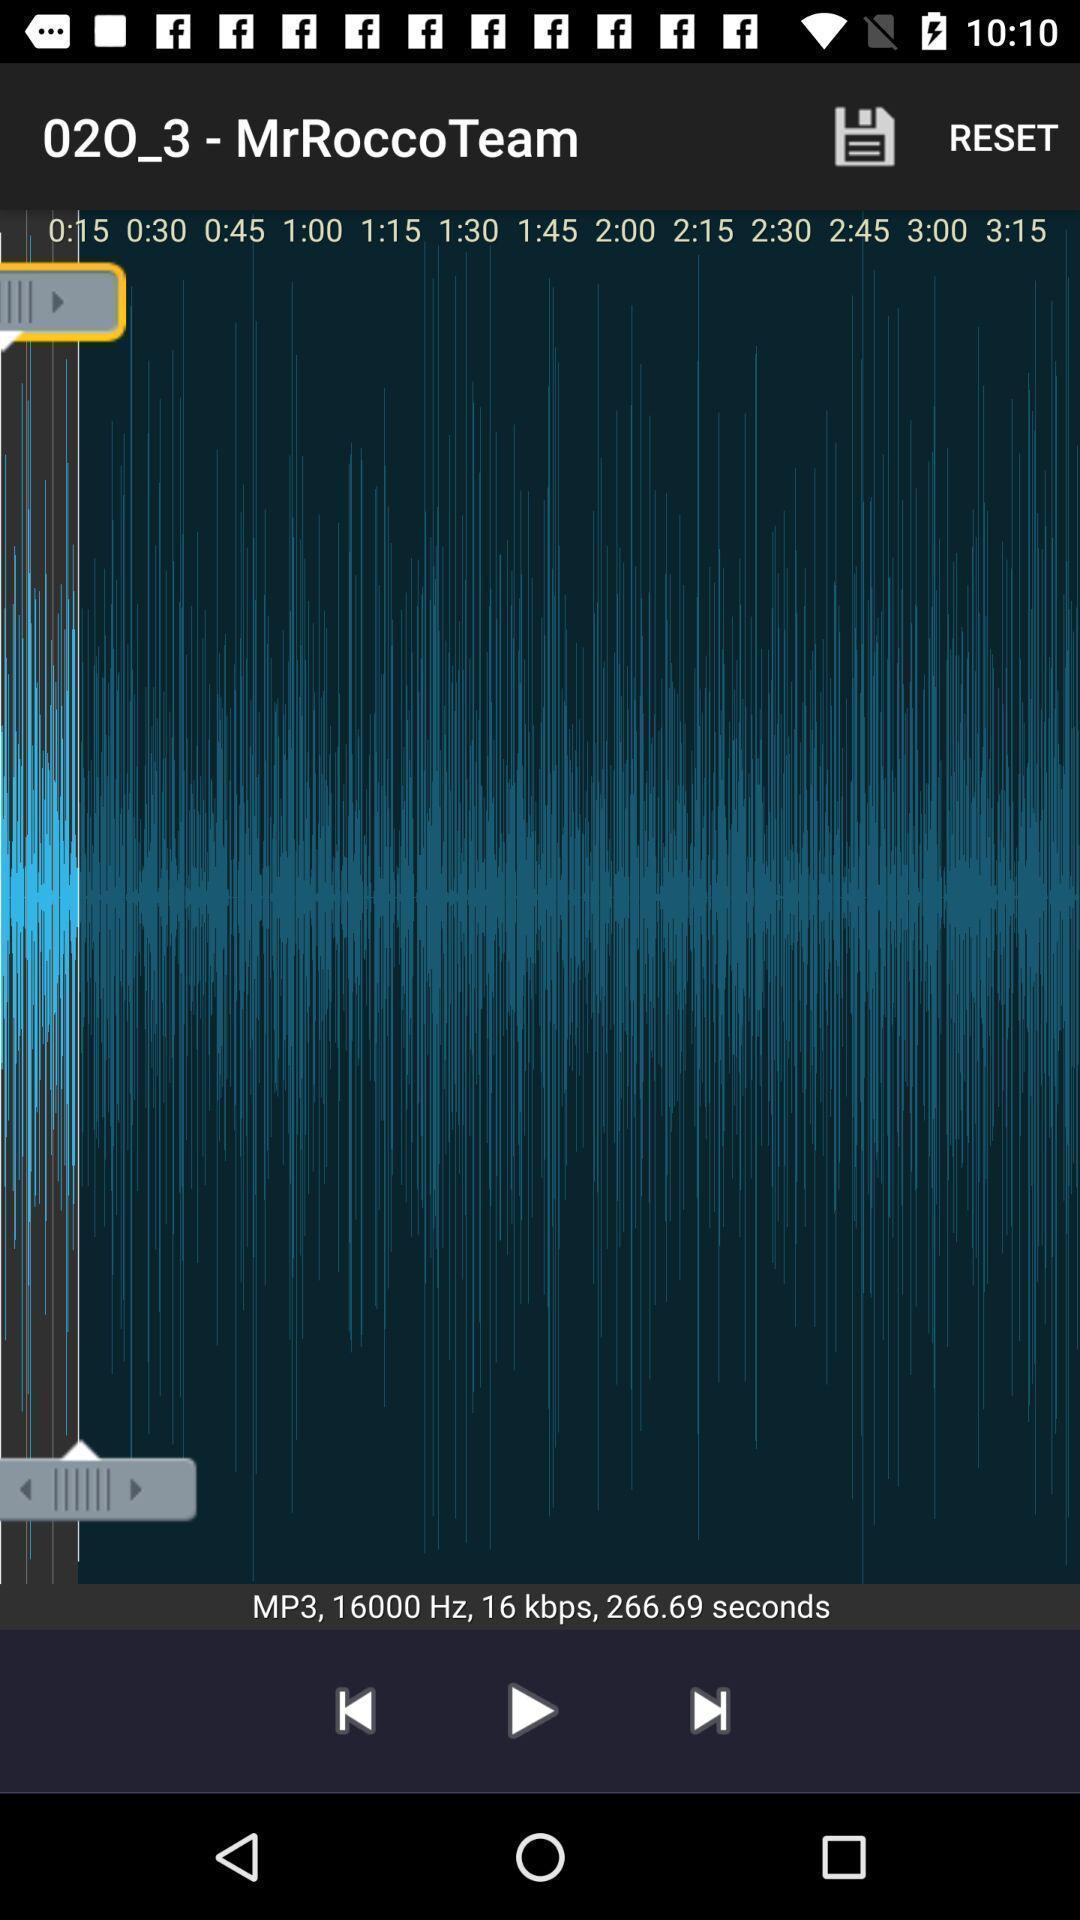Tell me about the visual elements in this screen capture. Page displays levels to cut a song. 